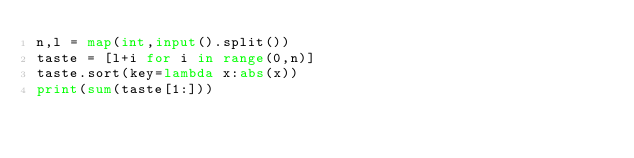Convert code to text. <code><loc_0><loc_0><loc_500><loc_500><_Python_>n,l = map(int,input().split())
taste = [l+i for i in range(0,n)]
taste.sort(key=lambda x:abs(x))
print(sum(taste[1:]))</code> 